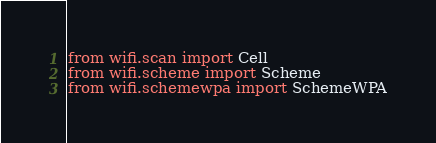Convert code to text. <code><loc_0><loc_0><loc_500><loc_500><_Python_>from wifi.scan import Cell
from wifi.scheme import Scheme
from wifi.schemewpa import SchemeWPA
</code> 